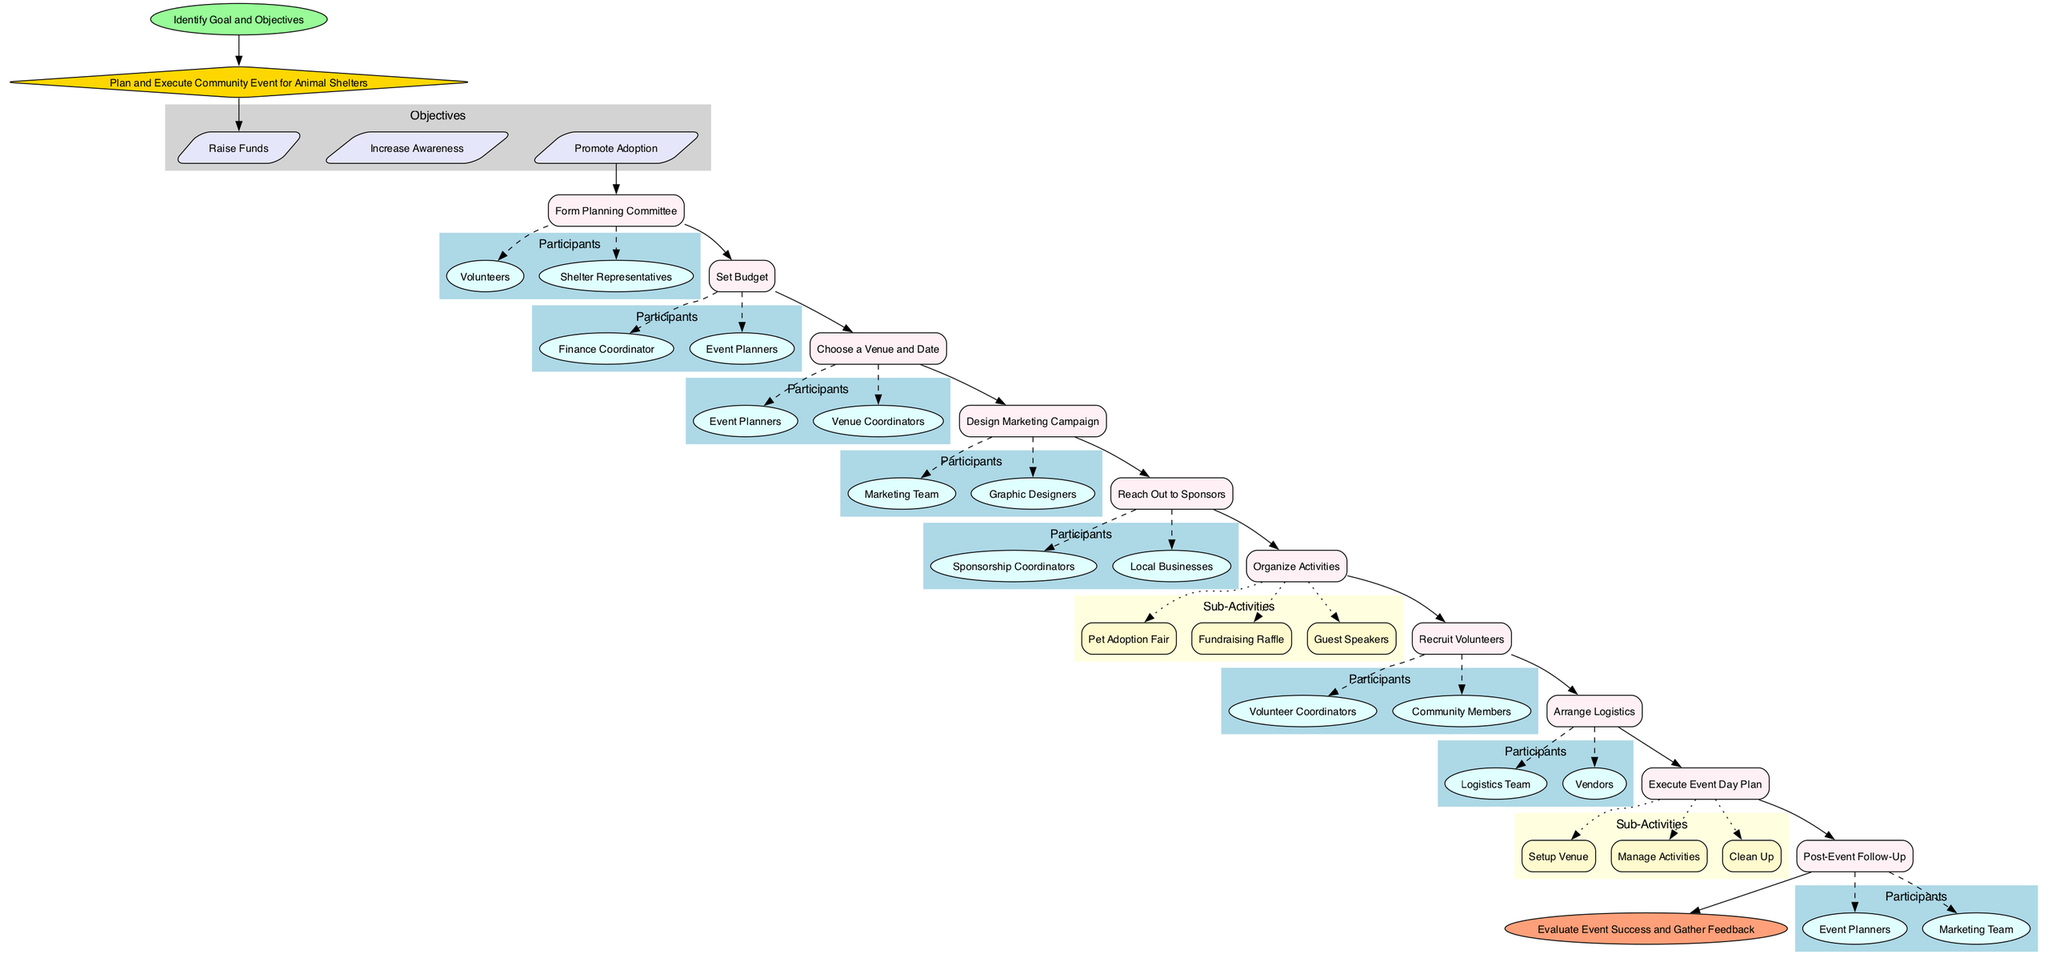What is the first step in the event planning process? The first step in the flowchart is the "Identify Goal and Objectives." This is directly connected to the StartEvent node, indicating it is the initial action to take.
Answer: Identify Goal and Objectives How many objectives are there in total? The diagram shows three objectives listed under the Objectives cluster. Each objective is connected to the Goal node, indicating they are individual components of the event planning process.
Answer: Three What is the last activity before the evaluation of the event success? The last activity before reaching the EndEvent is the "Post-Event Follow-Up." This connects the previous activities to the event's conclusion, illustrating the process's end.
Answer: Post-Event Follow-Up Who are the participants involved in the "Design Marketing Campaign"? The participants listed for this activity are the "Marketing Team" and "Graphic Designers." They are part of the Participants subgraph under the Design Marketing Campaign node, representing those involved in this specific activity.
Answer: Marketing Team, Graphic Designers How many sub-activities are listed under "Organize Activities"? There are three sub-activities outlined under the "Organize Activities" node: "Pet Adoption Fair," "Fundraising Raffle," and "Guest Speakers." Each one is connected through a dotted line indicating they are components of the overall activity.
Answer: Three What is the main goal of planning this community event? The main goal stated in the diagram is "Plan and Execute Community Event for Animal Shelters." This is represented in the Goal node, deriving from the StartEvent.
Answer: Plan and Execute Community Event for Animal Shelters Which activity immediately follows setting the budget? The activity that follows "Set Budget" is "Choose a Venue and Date." This shows the sequential flow of activities leading from budget consideration to logistics planning.
Answer: Choose a Venue and Date How many total activities are there in the planning process? The diagram contains a total of ten activities listed, including the organizational and execution-related tasks that contribute to the event planning process.
Answer: Ten 